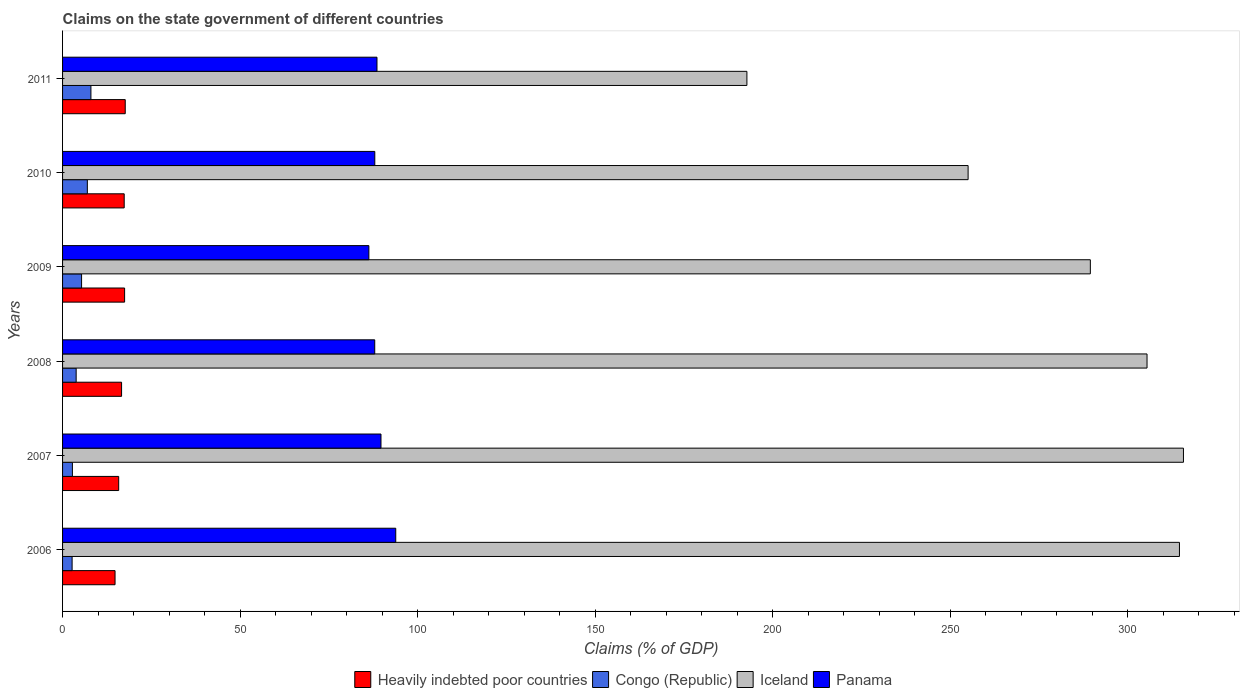How many different coloured bars are there?
Ensure brevity in your answer.  4. Are the number of bars per tick equal to the number of legend labels?
Your answer should be compact. Yes. Are the number of bars on each tick of the Y-axis equal?
Give a very brief answer. Yes. How many bars are there on the 3rd tick from the top?
Your answer should be very brief. 4. How many bars are there on the 1st tick from the bottom?
Keep it short and to the point. 4. What is the label of the 4th group of bars from the top?
Offer a terse response. 2008. In how many cases, is the number of bars for a given year not equal to the number of legend labels?
Give a very brief answer. 0. What is the percentage of GDP claimed on the state government in Congo (Republic) in 2009?
Give a very brief answer. 5.35. Across all years, what is the maximum percentage of GDP claimed on the state government in Iceland?
Your answer should be compact. 315.68. Across all years, what is the minimum percentage of GDP claimed on the state government in Panama?
Your response must be concise. 86.27. In which year was the percentage of GDP claimed on the state government in Congo (Republic) maximum?
Give a very brief answer. 2011. What is the total percentage of GDP claimed on the state government in Panama in the graph?
Ensure brevity in your answer.  534.18. What is the difference between the percentage of GDP claimed on the state government in Panama in 2006 and that in 2009?
Provide a short and direct response. 7.57. What is the difference between the percentage of GDP claimed on the state government in Heavily indebted poor countries in 2009 and the percentage of GDP claimed on the state government in Congo (Republic) in 2008?
Make the answer very short. 13.64. What is the average percentage of GDP claimed on the state government in Iceland per year?
Make the answer very short. 278.81. In the year 2007, what is the difference between the percentage of GDP claimed on the state government in Heavily indebted poor countries and percentage of GDP claimed on the state government in Congo (Republic)?
Your answer should be very brief. 13.03. What is the ratio of the percentage of GDP claimed on the state government in Iceland in 2006 to that in 2008?
Your response must be concise. 1.03. What is the difference between the highest and the second highest percentage of GDP claimed on the state government in Panama?
Provide a succinct answer. 4.16. What is the difference between the highest and the lowest percentage of GDP claimed on the state government in Iceland?
Offer a terse response. 122.94. In how many years, is the percentage of GDP claimed on the state government in Panama greater than the average percentage of GDP claimed on the state government in Panama taken over all years?
Your answer should be compact. 2. What does the 3rd bar from the top in 2011 represents?
Ensure brevity in your answer.  Congo (Republic). What does the 4th bar from the bottom in 2008 represents?
Offer a very short reply. Panama. Is it the case that in every year, the sum of the percentage of GDP claimed on the state government in Iceland and percentage of GDP claimed on the state government in Congo (Republic) is greater than the percentage of GDP claimed on the state government in Panama?
Provide a short and direct response. Yes. How many bars are there?
Provide a short and direct response. 24. What is the difference between two consecutive major ticks on the X-axis?
Your answer should be very brief. 50. Does the graph contain any zero values?
Keep it short and to the point. No. Does the graph contain grids?
Ensure brevity in your answer.  No. How many legend labels are there?
Make the answer very short. 4. What is the title of the graph?
Your response must be concise. Claims on the state government of different countries. Does "Caribbean small states" appear as one of the legend labels in the graph?
Keep it short and to the point. No. What is the label or title of the X-axis?
Offer a terse response. Claims (% of GDP). What is the Claims (% of GDP) in Heavily indebted poor countries in 2006?
Your answer should be very brief. 14.78. What is the Claims (% of GDP) in Congo (Republic) in 2006?
Keep it short and to the point. 2.69. What is the Claims (% of GDP) of Iceland in 2006?
Offer a very short reply. 314.55. What is the Claims (% of GDP) in Panama in 2006?
Your response must be concise. 93.84. What is the Claims (% of GDP) of Heavily indebted poor countries in 2007?
Make the answer very short. 15.81. What is the Claims (% of GDP) of Congo (Republic) in 2007?
Your answer should be compact. 2.77. What is the Claims (% of GDP) of Iceland in 2007?
Keep it short and to the point. 315.68. What is the Claims (% of GDP) of Panama in 2007?
Offer a very short reply. 89.68. What is the Claims (% of GDP) in Heavily indebted poor countries in 2008?
Your answer should be very brief. 16.62. What is the Claims (% of GDP) in Congo (Republic) in 2008?
Provide a succinct answer. 3.83. What is the Claims (% of GDP) of Iceland in 2008?
Offer a terse response. 305.42. What is the Claims (% of GDP) in Panama in 2008?
Keep it short and to the point. 87.92. What is the Claims (% of GDP) in Heavily indebted poor countries in 2009?
Offer a terse response. 17.47. What is the Claims (% of GDP) in Congo (Republic) in 2009?
Keep it short and to the point. 5.35. What is the Claims (% of GDP) in Iceland in 2009?
Your answer should be compact. 289.45. What is the Claims (% of GDP) of Panama in 2009?
Your response must be concise. 86.27. What is the Claims (% of GDP) in Heavily indebted poor countries in 2010?
Provide a short and direct response. 17.36. What is the Claims (% of GDP) in Congo (Republic) in 2010?
Your answer should be very brief. 6.98. What is the Claims (% of GDP) in Iceland in 2010?
Offer a very short reply. 255.03. What is the Claims (% of GDP) of Panama in 2010?
Provide a short and direct response. 87.94. What is the Claims (% of GDP) in Heavily indebted poor countries in 2011?
Make the answer very short. 17.65. What is the Claims (% of GDP) in Congo (Republic) in 2011?
Make the answer very short. 7.99. What is the Claims (% of GDP) of Iceland in 2011?
Ensure brevity in your answer.  192.73. What is the Claims (% of GDP) in Panama in 2011?
Give a very brief answer. 88.55. Across all years, what is the maximum Claims (% of GDP) of Heavily indebted poor countries?
Give a very brief answer. 17.65. Across all years, what is the maximum Claims (% of GDP) in Congo (Republic)?
Offer a terse response. 7.99. Across all years, what is the maximum Claims (% of GDP) in Iceland?
Your answer should be compact. 315.68. Across all years, what is the maximum Claims (% of GDP) in Panama?
Provide a short and direct response. 93.84. Across all years, what is the minimum Claims (% of GDP) of Heavily indebted poor countries?
Offer a very short reply. 14.78. Across all years, what is the minimum Claims (% of GDP) in Congo (Republic)?
Your answer should be very brief. 2.69. Across all years, what is the minimum Claims (% of GDP) in Iceland?
Provide a short and direct response. 192.73. Across all years, what is the minimum Claims (% of GDP) of Panama?
Offer a very short reply. 86.27. What is the total Claims (% of GDP) in Heavily indebted poor countries in the graph?
Give a very brief answer. 99.69. What is the total Claims (% of GDP) of Congo (Republic) in the graph?
Ensure brevity in your answer.  29.61. What is the total Claims (% of GDP) in Iceland in the graph?
Your answer should be very brief. 1672.86. What is the total Claims (% of GDP) of Panama in the graph?
Offer a terse response. 534.18. What is the difference between the Claims (% of GDP) in Heavily indebted poor countries in 2006 and that in 2007?
Your answer should be compact. -1.03. What is the difference between the Claims (% of GDP) of Congo (Republic) in 2006 and that in 2007?
Offer a very short reply. -0.08. What is the difference between the Claims (% of GDP) in Iceland in 2006 and that in 2007?
Provide a short and direct response. -1.13. What is the difference between the Claims (% of GDP) in Panama in 2006 and that in 2007?
Your answer should be compact. 4.16. What is the difference between the Claims (% of GDP) in Heavily indebted poor countries in 2006 and that in 2008?
Your response must be concise. -1.84. What is the difference between the Claims (% of GDP) in Congo (Republic) in 2006 and that in 2008?
Ensure brevity in your answer.  -1.14. What is the difference between the Claims (% of GDP) in Iceland in 2006 and that in 2008?
Give a very brief answer. 9.13. What is the difference between the Claims (% of GDP) in Panama in 2006 and that in 2008?
Give a very brief answer. 5.92. What is the difference between the Claims (% of GDP) in Heavily indebted poor countries in 2006 and that in 2009?
Your answer should be very brief. -2.69. What is the difference between the Claims (% of GDP) in Congo (Republic) in 2006 and that in 2009?
Provide a short and direct response. -2.67. What is the difference between the Claims (% of GDP) in Iceland in 2006 and that in 2009?
Keep it short and to the point. 25.09. What is the difference between the Claims (% of GDP) in Panama in 2006 and that in 2009?
Provide a short and direct response. 7.57. What is the difference between the Claims (% of GDP) in Heavily indebted poor countries in 2006 and that in 2010?
Make the answer very short. -2.58. What is the difference between the Claims (% of GDP) in Congo (Republic) in 2006 and that in 2010?
Offer a very short reply. -4.29. What is the difference between the Claims (% of GDP) of Iceland in 2006 and that in 2010?
Provide a short and direct response. 59.52. What is the difference between the Claims (% of GDP) of Panama in 2006 and that in 2010?
Provide a succinct answer. 5.9. What is the difference between the Claims (% of GDP) in Heavily indebted poor countries in 2006 and that in 2011?
Your answer should be very brief. -2.87. What is the difference between the Claims (% of GDP) of Congo (Republic) in 2006 and that in 2011?
Make the answer very short. -5.3. What is the difference between the Claims (% of GDP) in Iceland in 2006 and that in 2011?
Provide a succinct answer. 121.81. What is the difference between the Claims (% of GDP) in Panama in 2006 and that in 2011?
Offer a terse response. 5.29. What is the difference between the Claims (% of GDP) in Heavily indebted poor countries in 2007 and that in 2008?
Ensure brevity in your answer.  -0.81. What is the difference between the Claims (% of GDP) in Congo (Republic) in 2007 and that in 2008?
Provide a short and direct response. -1.06. What is the difference between the Claims (% of GDP) in Iceland in 2007 and that in 2008?
Offer a terse response. 10.26. What is the difference between the Claims (% of GDP) of Panama in 2007 and that in 2008?
Provide a succinct answer. 1.76. What is the difference between the Claims (% of GDP) of Heavily indebted poor countries in 2007 and that in 2009?
Offer a terse response. -1.67. What is the difference between the Claims (% of GDP) in Congo (Republic) in 2007 and that in 2009?
Ensure brevity in your answer.  -2.58. What is the difference between the Claims (% of GDP) in Iceland in 2007 and that in 2009?
Offer a terse response. 26.22. What is the difference between the Claims (% of GDP) of Panama in 2007 and that in 2009?
Provide a short and direct response. 3.41. What is the difference between the Claims (% of GDP) of Heavily indebted poor countries in 2007 and that in 2010?
Your response must be concise. -1.55. What is the difference between the Claims (% of GDP) of Congo (Republic) in 2007 and that in 2010?
Provide a short and direct response. -4.21. What is the difference between the Claims (% of GDP) of Iceland in 2007 and that in 2010?
Give a very brief answer. 60.65. What is the difference between the Claims (% of GDP) in Panama in 2007 and that in 2010?
Your answer should be compact. 1.74. What is the difference between the Claims (% of GDP) in Heavily indebted poor countries in 2007 and that in 2011?
Your answer should be compact. -1.84. What is the difference between the Claims (% of GDP) in Congo (Republic) in 2007 and that in 2011?
Give a very brief answer. -5.21. What is the difference between the Claims (% of GDP) of Iceland in 2007 and that in 2011?
Your answer should be very brief. 122.94. What is the difference between the Claims (% of GDP) of Panama in 2007 and that in 2011?
Ensure brevity in your answer.  1.13. What is the difference between the Claims (% of GDP) of Heavily indebted poor countries in 2008 and that in 2009?
Offer a very short reply. -0.85. What is the difference between the Claims (% of GDP) of Congo (Republic) in 2008 and that in 2009?
Make the answer very short. -1.53. What is the difference between the Claims (% of GDP) in Iceland in 2008 and that in 2009?
Your answer should be very brief. 15.96. What is the difference between the Claims (% of GDP) in Panama in 2008 and that in 2009?
Give a very brief answer. 1.65. What is the difference between the Claims (% of GDP) of Heavily indebted poor countries in 2008 and that in 2010?
Your answer should be compact. -0.74. What is the difference between the Claims (% of GDP) in Congo (Republic) in 2008 and that in 2010?
Offer a very short reply. -3.15. What is the difference between the Claims (% of GDP) in Iceland in 2008 and that in 2010?
Make the answer very short. 50.39. What is the difference between the Claims (% of GDP) in Panama in 2008 and that in 2010?
Your answer should be very brief. -0.02. What is the difference between the Claims (% of GDP) in Heavily indebted poor countries in 2008 and that in 2011?
Provide a succinct answer. -1.03. What is the difference between the Claims (% of GDP) of Congo (Republic) in 2008 and that in 2011?
Provide a short and direct response. -4.16. What is the difference between the Claims (% of GDP) of Iceland in 2008 and that in 2011?
Your response must be concise. 112.69. What is the difference between the Claims (% of GDP) of Panama in 2008 and that in 2011?
Make the answer very short. -0.63. What is the difference between the Claims (% of GDP) of Heavily indebted poor countries in 2009 and that in 2010?
Give a very brief answer. 0.12. What is the difference between the Claims (% of GDP) in Congo (Republic) in 2009 and that in 2010?
Provide a short and direct response. -1.62. What is the difference between the Claims (% of GDP) in Iceland in 2009 and that in 2010?
Keep it short and to the point. 34.43. What is the difference between the Claims (% of GDP) in Panama in 2009 and that in 2010?
Ensure brevity in your answer.  -1.67. What is the difference between the Claims (% of GDP) of Heavily indebted poor countries in 2009 and that in 2011?
Your response must be concise. -0.18. What is the difference between the Claims (% of GDP) in Congo (Republic) in 2009 and that in 2011?
Your response must be concise. -2.63. What is the difference between the Claims (% of GDP) in Iceland in 2009 and that in 2011?
Ensure brevity in your answer.  96.72. What is the difference between the Claims (% of GDP) of Panama in 2009 and that in 2011?
Your answer should be compact. -2.28. What is the difference between the Claims (% of GDP) in Heavily indebted poor countries in 2010 and that in 2011?
Ensure brevity in your answer.  -0.29. What is the difference between the Claims (% of GDP) of Congo (Republic) in 2010 and that in 2011?
Give a very brief answer. -1.01. What is the difference between the Claims (% of GDP) in Iceland in 2010 and that in 2011?
Offer a terse response. 62.29. What is the difference between the Claims (% of GDP) in Panama in 2010 and that in 2011?
Offer a very short reply. -0.61. What is the difference between the Claims (% of GDP) in Heavily indebted poor countries in 2006 and the Claims (% of GDP) in Congo (Republic) in 2007?
Offer a terse response. 12.01. What is the difference between the Claims (% of GDP) of Heavily indebted poor countries in 2006 and the Claims (% of GDP) of Iceland in 2007?
Give a very brief answer. -300.89. What is the difference between the Claims (% of GDP) of Heavily indebted poor countries in 2006 and the Claims (% of GDP) of Panama in 2007?
Offer a very short reply. -74.9. What is the difference between the Claims (% of GDP) of Congo (Republic) in 2006 and the Claims (% of GDP) of Iceland in 2007?
Make the answer very short. -312.99. What is the difference between the Claims (% of GDP) of Congo (Republic) in 2006 and the Claims (% of GDP) of Panama in 2007?
Give a very brief answer. -86.99. What is the difference between the Claims (% of GDP) in Iceland in 2006 and the Claims (% of GDP) in Panama in 2007?
Your answer should be compact. 224.87. What is the difference between the Claims (% of GDP) of Heavily indebted poor countries in 2006 and the Claims (% of GDP) of Congo (Republic) in 2008?
Your answer should be compact. 10.95. What is the difference between the Claims (% of GDP) of Heavily indebted poor countries in 2006 and the Claims (% of GDP) of Iceland in 2008?
Make the answer very short. -290.64. What is the difference between the Claims (% of GDP) of Heavily indebted poor countries in 2006 and the Claims (% of GDP) of Panama in 2008?
Provide a short and direct response. -73.14. What is the difference between the Claims (% of GDP) in Congo (Republic) in 2006 and the Claims (% of GDP) in Iceland in 2008?
Offer a terse response. -302.73. What is the difference between the Claims (% of GDP) in Congo (Republic) in 2006 and the Claims (% of GDP) in Panama in 2008?
Offer a very short reply. -85.23. What is the difference between the Claims (% of GDP) of Iceland in 2006 and the Claims (% of GDP) of Panama in 2008?
Provide a short and direct response. 226.63. What is the difference between the Claims (% of GDP) in Heavily indebted poor countries in 2006 and the Claims (% of GDP) in Congo (Republic) in 2009?
Offer a very short reply. 9.43. What is the difference between the Claims (% of GDP) of Heavily indebted poor countries in 2006 and the Claims (% of GDP) of Iceland in 2009?
Your response must be concise. -274.67. What is the difference between the Claims (% of GDP) in Heavily indebted poor countries in 2006 and the Claims (% of GDP) in Panama in 2009?
Provide a succinct answer. -71.48. What is the difference between the Claims (% of GDP) of Congo (Republic) in 2006 and the Claims (% of GDP) of Iceland in 2009?
Make the answer very short. -286.77. What is the difference between the Claims (% of GDP) in Congo (Republic) in 2006 and the Claims (% of GDP) in Panama in 2009?
Offer a terse response. -83.58. What is the difference between the Claims (% of GDP) of Iceland in 2006 and the Claims (% of GDP) of Panama in 2009?
Provide a succinct answer. 228.28. What is the difference between the Claims (% of GDP) in Heavily indebted poor countries in 2006 and the Claims (% of GDP) in Congo (Republic) in 2010?
Make the answer very short. 7.8. What is the difference between the Claims (% of GDP) in Heavily indebted poor countries in 2006 and the Claims (% of GDP) in Iceland in 2010?
Your answer should be very brief. -240.25. What is the difference between the Claims (% of GDP) in Heavily indebted poor countries in 2006 and the Claims (% of GDP) in Panama in 2010?
Offer a very short reply. -73.16. What is the difference between the Claims (% of GDP) of Congo (Republic) in 2006 and the Claims (% of GDP) of Iceland in 2010?
Make the answer very short. -252.34. What is the difference between the Claims (% of GDP) in Congo (Republic) in 2006 and the Claims (% of GDP) in Panama in 2010?
Ensure brevity in your answer.  -85.25. What is the difference between the Claims (% of GDP) in Iceland in 2006 and the Claims (% of GDP) in Panama in 2010?
Keep it short and to the point. 226.61. What is the difference between the Claims (% of GDP) in Heavily indebted poor countries in 2006 and the Claims (% of GDP) in Congo (Republic) in 2011?
Offer a very short reply. 6.79. What is the difference between the Claims (% of GDP) in Heavily indebted poor countries in 2006 and the Claims (% of GDP) in Iceland in 2011?
Offer a very short reply. -177.95. What is the difference between the Claims (% of GDP) in Heavily indebted poor countries in 2006 and the Claims (% of GDP) in Panama in 2011?
Offer a very short reply. -73.77. What is the difference between the Claims (% of GDP) in Congo (Republic) in 2006 and the Claims (% of GDP) in Iceland in 2011?
Your response must be concise. -190.05. What is the difference between the Claims (% of GDP) of Congo (Republic) in 2006 and the Claims (% of GDP) of Panama in 2011?
Offer a terse response. -85.86. What is the difference between the Claims (% of GDP) in Iceland in 2006 and the Claims (% of GDP) in Panama in 2011?
Your response must be concise. 226. What is the difference between the Claims (% of GDP) of Heavily indebted poor countries in 2007 and the Claims (% of GDP) of Congo (Republic) in 2008?
Provide a short and direct response. 11.98. What is the difference between the Claims (% of GDP) in Heavily indebted poor countries in 2007 and the Claims (% of GDP) in Iceland in 2008?
Give a very brief answer. -289.61. What is the difference between the Claims (% of GDP) in Heavily indebted poor countries in 2007 and the Claims (% of GDP) in Panama in 2008?
Offer a very short reply. -72.11. What is the difference between the Claims (% of GDP) of Congo (Republic) in 2007 and the Claims (% of GDP) of Iceland in 2008?
Keep it short and to the point. -302.65. What is the difference between the Claims (% of GDP) of Congo (Republic) in 2007 and the Claims (% of GDP) of Panama in 2008?
Ensure brevity in your answer.  -85.15. What is the difference between the Claims (% of GDP) of Iceland in 2007 and the Claims (% of GDP) of Panama in 2008?
Give a very brief answer. 227.76. What is the difference between the Claims (% of GDP) of Heavily indebted poor countries in 2007 and the Claims (% of GDP) of Congo (Republic) in 2009?
Ensure brevity in your answer.  10.45. What is the difference between the Claims (% of GDP) in Heavily indebted poor countries in 2007 and the Claims (% of GDP) in Iceland in 2009?
Ensure brevity in your answer.  -273.65. What is the difference between the Claims (% of GDP) of Heavily indebted poor countries in 2007 and the Claims (% of GDP) of Panama in 2009?
Offer a very short reply. -70.46. What is the difference between the Claims (% of GDP) in Congo (Republic) in 2007 and the Claims (% of GDP) in Iceland in 2009?
Your answer should be very brief. -286.68. What is the difference between the Claims (% of GDP) in Congo (Republic) in 2007 and the Claims (% of GDP) in Panama in 2009?
Provide a succinct answer. -83.49. What is the difference between the Claims (% of GDP) of Iceland in 2007 and the Claims (% of GDP) of Panama in 2009?
Your answer should be compact. 229.41. What is the difference between the Claims (% of GDP) in Heavily indebted poor countries in 2007 and the Claims (% of GDP) in Congo (Republic) in 2010?
Offer a very short reply. 8.83. What is the difference between the Claims (% of GDP) in Heavily indebted poor countries in 2007 and the Claims (% of GDP) in Iceland in 2010?
Provide a succinct answer. -239.22. What is the difference between the Claims (% of GDP) in Heavily indebted poor countries in 2007 and the Claims (% of GDP) in Panama in 2010?
Offer a very short reply. -72.13. What is the difference between the Claims (% of GDP) in Congo (Republic) in 2007 and the Claims (% of GDP) in Iceland in 2010?
Provide a short and direct response. -252.26. What is the difference between the Claims (% of GDP) of Congo (Republic) in 2007 and the Claims (% of GDP) of Panama in 2010?
Keep it short and to the point. -85.16. What is the difference between the Claims (% of GDP) of Iceland in 2007 and the Claims (% of GDP) of Panama in 2010?
Make the answer very short. 227.74. What is the difference between the Claims (% of GDP) in Heavily indebted poor countries in 2007 and the Claims (% of GDP) in Congo (Republic) in 2011?
Offer a terse response. 7.82. What is the difference between the Claims (% of GDP) of Heavily indebted poor countries in 2007 and the Claims (% of GDP) of Iceland in 2011?
Ensure brevity in your answer.  -176.93. What is the difference between the Claims (% of GDP) of Heavily indebted poor countries in 2007 and the Claims (% of GDP) of Panama in 2011?
Your answer should be compact. -72.74. What is the difference between the Claims (% of GDP) of Congo (Republic) in 2007 and the Claims (% of GDP) of Iceland in 2011?
Give a very brief answer. -189.96. What is the difference between the Claims (% of GDP) of Congo (Republic) in 2007 and the Claims (% of GDP) of Panama in 2011?
Your response must be concise. -85.78. What is the difference between the Claims (% of GDP) in Iceland in 2007 and the Claims (% of GDP) in Panama in 2011?
Your response must be concise. 227.13. What is the difference between the Claims (% of GDP) in Heavily indebted poor countries in 2008 and the Claims (% of GDP) in Congo (Republic) in 2009?
Give a very brief answer. 11.27. What is the difference between the Claims (% of GDP) in Heavily indebted poor countries in 2008 and the Claims (% of GDP) in Iceland in 2009?
Provide a short and direct response. -272.83. What is the difference between the Claims (% of GDP) in Heavily indebted poor countries in 2008 and the Claims (% of GDP) in Panama in 2009?
Offer a terse response. -69.65. What is the difference between the Claims (% of GDP) in Congo (Republic) in 2008 and the Claims (% of GDP) in Iceland in 2009?
Keep it short and to the point. -285.63. What is the difference between the Claims (% of GDP) of Congo (Republic) in 2008 and the Claims (% of GDP) of Panama in 2009?
Make the answer very short. -82.44. What is the difference between the Claims (% of GDP) in Iceland in 2008 and the Claims (% of GDP) in Panama in 2009?
Provide a short and direct response. 219.15. What is the difference between the Claims (% of GDP) in Heavily indebted poor countries in 2008 and the Claims (% of GDP) in Congo (Republic) in 2010?
Give a very brief answer. 9.64. What is the difference between the Claims (% of GDP) of Heavily indebted poor countries in 2008 and the Claims (% of GDP) of Iceland in 2010?
Provide a short and direct response. -238.41. What is the difference between the Claims (% of GDP) of Heavily indebted poor countries in 2008 and the Claims (% of GDP) of Panama in 2010?
Offer a terse response. -71.32. What is the difference between the Claims (% of GDP) of Congo (Republic) in 2008 and the Claims (% of GDP) of Iceland in 2010?
Offer a terse response. -251.2. What is the difference between the Claims (% of GDP) in Congo (Republic) in 2008 and the Claims (% of GDP) in Panama in 2010?
Your answer should be compact. -84.11. What is the difference between the Claims (% of GDP) in Iceland in 2008 and the Claims (% of GDP) in Panama in 2010?
Offer a terse response. 217.48. What is the difference between the Claims (% of GDP) of Heavily indebted poor countries in 2008 and the Claims (% of GDP) of Congo (Republic) in 2011?
Make the answer very short. 8.63. What is the difference between the Claims (% of GDP) of Heavily indebted poor countries in 2008 and the Claims (% of GDP) of Iceland in 2011?
Your answer should be very brief. -176.11. What is the difference between the Claims (% of GDP) in Heavily indebted poor countries in 2008 and the Claims (% of GDP) in Panama in 2011?
Your answer should be compact. -71.93. What is the difference between the Claims (% of GDP) of Congo (Republic) in 2008 and the Claims (% of GDP) of Iceland in 2011?
Make the answer very short. -188.91. What is the difference between the Claims (% of GDP) of Congo (Republic) in 2008 and the Claims (% of GDP) of Panama in 2011?
Your answer should be compact. -84.72. What is the difference between the Claims (% of GDP) of Iceland in 2008 and the Claims (% of GDP) of Panama in 2011?
Offer a very short reply. 216.87. What is the difference between the Claims (% of GDP) of Heavily indebted poor countries in 2009 and the Claims (% of GDP) of Congo (Republic) in 2010?
Your answer should be compact. 10.49. What is the difference between the Claims (% of GDP) in Heavily indebted poor countries in 2009 and the Claims (% of GDP) in Iceland in 2010?
Ensure brevity in your answer.  -237.56. What is the difference between the Claims (% of GDP) of Heavily indebted poor countries in 2009 and the Claims (% of GDP) of Panama in 2010?
Your answer should be compact. -70.46. What is the difference between the Claims (% of GDP) in Congo (Republic) in 2009 and the Claims (% of GDP) in Iceland in 2010?
Your answer should be compact. -249.67. What is the difference between the Claims (% of GDP) of Congo (Republic) in 2009 and the Claims (% of GDP) of Panama in 2010?
Ensure brevity in your answer.  -82.58. What is the difference between the Claims (% of GDP) of Iceland in 2009 and the Claims (% of GDP) of Panama in 2010?
Make the answer very short. 201.52. What is the difference between the Claims (% of GDP) in Heavily indebted poor countries in 2009 and the Claims (% of GDP) in Congo (Republic) in 2011?
Your response must be concise. 9.49. What is the difference between the Claims (% of GDP) in Heavily indebted poor countries in 2009 and the Claims (% of GDP) in Iceland in 2011?
Your response must be concise. -175.26. What is the difference between the Claims (% of GDP) of Heavily indebted poor countries in 2009 and the Claims (% of GDP) of Panama in 2011?
Make the answer very short. -71.08. What is the difference between the Claims (% of GDP) in Congo (Republic) in 2009 and the Claims (% of GDP) in Iceland in 2011?
Your answer should be compact. -187.38. What is the difference between the Claims (% of GDP) in Congo (Republic) in 2009 and the Claims (% of GDP) in Panama in 2011?
Your answer should be compact. -83.2. What is the difference between the Claims (% of GDP) of Iceland in 2009 and the Claims (% of GDP) of Panama in 2011?
Offer a very short reply. 200.91. What is the difference between the Claims (% of GDP) of Heavily indebted poor countries in 2010 and the Claims (% of GDP) of Congo (Republic) in 2011?
Offer a very short reply. 9.37. What is the difference between the Claims (% of GDP) in Heavily indebted poor countries in 2010 and the Claims (% of GDP) in Iceland in 2011?
Ensure brevity in your answer.  -175.38. What is the difference between the Claims (% of GDP) of Heavily indebted poor countries in 2010 and the Claims (% of GDP) of Panama in 2011?
Provide a succinct answer. -71.19. What is the difference between the Claims (% of GDP) of Congo (Republic) in 2010 and the Claims (% of GDP) of Iceland in 2011?
Offer a terse response. -185.75. What is the difference between the Claims (% of GDP) of Congo (Republic) in 2010 and the Claims (% of GDP) of Panama in 2011?
Your answer should be very brief. -81.57. What is the difference between the Claims (% of GDP) in Iceland in 2010 and the Claims (% of GDP) in Panama in 2011?
Ensure brevity in your answer.  166.48. What is the average Claims (% of GDP) in Heavily indebted poor countries per year?
Make the answer very short. 16.61. What is the average Claims (% of GDP) of Congo (Republic) per year?
Give a very brief answer. 4.93. What is the average Claims (% of GDP) in Iceland per year?
Provide a succinct answer. 278.81. What is the average Claims (% of GDP) in Panama per year?
Make the answer very short. 89.03. In the year 2006, what is the difference between the Claims (% of GDP) of Heavily indebted poor countries and Claims (% of GDP) of Congo (Republic)?
Your answer should be very brief. 12.09. In the year 2006, what is the difference between the Claims (% of GDP) of Heavily indebted poor countries and Claims (% of GDP) of Iceland?
Offer a terse response. -299.77. In the year 2006, what is the difference between the Claims (% of GDP) in Heavily indebted poor countries and Claims (% of GDP) in Panama?
Offer a very short reply. -79.06. In the year 2006, what is the difference between the Claims (% of GDP) in Congo (Republic) and Claims (% of GDP) in Iceland?
Make the answer very short. -311.86. In the year 2006, what is the difference between the Claims (% of GDP) of Congo (Republic) and Claims (% of GDP) of Panama?
Ensure brevity in your answer.  -91.15. In the year 2006, what is the difference between the Claims (% of GDP) in Iceland and Claims (% of GDP) in Panama?
Offer a very short reply. 220.71. In the year 2007, what is the difference between the Claims (% of GDP) in Heavily indebted poor countries and Claims (% of GDP) in Congo (Republic)?
Your response must be concise. 13.03. In the year 2007, what is the difference between the Claims (% of GDP) in Heavily indebted poor countries and Claims (% of GDP) in Iceland?
Keep it short and to the point. -299.87. In the year 2007, what is the difference between the Claims (% of GDP) in Heavily indebted poor countries and Claims (% of GDP) in Panama?
Ensure brevity in your answer.  -73.87. In the year 2007, what is the difference between the Claims (% of GDP) in Congo (Republic) and Claims (% of GDP) in Iceland?
Make the answer very short. -312.9. In the year 2007, what is the difference between the Claims (% of GDP) in Congo (Republic) and Claims (% of GDP) in Panama?
Offer a very short reply. -86.91. In the year 2007, what is the difference between the Claims (% of GDP) of Iceland and Claims (% of GDP) of Panama?
Your answer should be very brief. 226. In the year 2008, what is the difference between the Claims (% of GDP) in Heavily indebted poor countries and Claims (% of GDP) in Congo (Republic)?
Your answer should be compact. 12.79. In the year 2008, what is the difference between the Claims (% of GDP) in Heavily indebted poor countries and Claims (% of GDP) in Iceland?
Give a very brief answer. -288.8. In the year 2008, what is the difference between the Claims (% of GDP) in Heavily indebted poor countries and Claims (% of GDP) in Panama?
Keep it short and to the point. -71.3. In the year 2008, what is the difference between the Claims (% of GDP) of Congo (Republic) and Claims (% of GDP) of Iceland?
Keep it short and to the point. -301.59. In the year 2008, what is the difference between the Claims (% of GDP) in Congo (Republic) and Claims (% of GDP) in Panama?
Your answer should be compact. -84.09. In the year 2008, what is the difference between the Claims (% of GDP) in Iceland and Claims (% of GDP) in Panama?
Provide a succinct answer. 217.5. In the year 2009, what is the difference between the Claims (% of GDP) of Heavily indebted poor countries and Claims (% of GDP) of Congo (Republic)?
Provide a short and direct response. 12.12. In the year 2009, what is the difference between the Claims (% of GDP) in Heavily indebted poor countries and Claims (% of GDP) in Iceland?
Provide a succinct answer. -271.98. In the year 2009, what is the difference between the Claims (% of GDP) in Heavily indebted poor countries and Claims (% of GDP) in Panama?
Provide a succinct answer. -68.79. In the year 2009, what is the difference between the Claims (% of GDP) in Congo (Republic) and Claims (% of GDP) in Iceland?
Your answer should be very brief. -284.1. In the year 2009, what is the difference between the Claims (% of GDP) in Congo (Republic) and Claims (% of GDP) in Panama?
Your answer should be compact. -80.91. In the year 2009, what is the difference between the Claims (% of GDP) in Iceland and Claims (% of GDP) in Panama?
Your answer should be very brief. 203.19. In the year 2010, what is the difference between the Claims (% of GDP) in Heavily indebted poor countries and Claims (% of GDP) in Congo (Republic)?
Provide a succinct answer. 10.38. In the year 2010, what is the difference between the Claims (% of GDP) in Heavily indebted poor countries and Claims (% of GDP) in Iceland?
Provide a short and direct response. -237.67. In the year 2010, what is the difference between the Claims (% of GDP) in Heavily indebted poor countries and Claims (% of GDP) in Panama?
Provide a succinct answer. -70.58. In the year 2010, what is the difference between the Claims (% of GDP) in Congo (Republic) and Claims (% of GDP) in Iceland?
Give a very brief answer. -248.05. In the year 2010, what is the difference between the Claims (% of GDP) in Congo (Republic) and Claims (% of GDP) in Panama?
Keep it short and to the point. -80.96. In the year 2010, what is the difference between the Claims (% of GDP) in Iceland and Claims (% of GDP) in Panama?
Ensure brevity in your answer.  167.09. In the year 2011, what is the difference between the Claims (% of GDP) of Heavily indebted poor countries and Claims (% of GDP) of Congo (Republic)?
Your response must be concise. 9.66. In the year 2011, what is the difference between the Claims (% of GDP) of Heavily indebted poor countries and Claims (% of GDP) of Iceland?
Make the answer very short. -175.08. In the year 2011, what is the difference between the Claims (% of GDP) of Heavily indebted poor countries and Claims (% of GDP) of Panama?
Your answer should be compact. -70.9. In the year 2011, what is the difference between the Claims (% of GDP) of Congo (Republic) and Claims (% of GDP) of Iceland?
Keep it short and to the point. -184.75. In the year 2011, what is the difference between the Claims (% of GDP) of Congo (Republic) and Claims (% of GDP) of Panama?
Ensure brevity in your answer.  -80.56. In the year 2011, what is the difference between the Claims (% of GDP) of Iceland and Claims (% of GDP) of Panama?
Your response must be concise. 104.18. What is the ratio of the Claims (% of GDP) in Heavily indebted poor countries in 2006 to that in 2007?
Keep it short and to the point. 0.94. What is the ratio of the Claims (% of GDP) of Congo (Republic) in 2006 to that in 2007?
Make the answer very short. 0.97. What is the ratio of the Claims (% of GDP) of Panama in 2006 to that in 2007?
Ensure brevity in your answer.  1.05. What is the ratio of the Claims (% of GDP) in Heavily indebted poor countries in 2006 to that in 2008?
Ensure brevity in your answer.  0.89. What is the ratio of the Claims (% of GDP) of Congo (Republic) in 2006 to that in 2008?
Your answer should be compact. 0.7. What is the ratio of the Claims (% of GDP) in Iceland in 2006 to that in 2008?
Your answer should be compact. 1.03. What is the ratio of the Claims (% of GDP) of Panama in 2006 to that in 2008?
Give a very brief answer. 1.07. What is the ratio of the Claims (% of GDP) in Heavily indebted poor countries in 2006 to that in 2009?
Ensure brevity in your answer.  0.85. What is the ratio of the Claims (% of GDP) in Congo (Republic) in 2006 to that in 2009?
Your answer should be compact. 0.5. What is the ratio of the Claims (% of GDP) of Iceland in 2006 to that in 2009?
Make the answer very short. 1.09. What is the ratio of the Claims (% of GDP) of Panama in 2006 to that in 2009?
Your answer should be compact. 1.09. What is the ratio of the Claims (% of GDP) of Heavily indebted poor countries in 2006 to that in 2010?
Provide a succinct answer. 0.85. What is the ratio of the Claims (% of GDP) of Congo (Republic) in 2006 to that in 2010?
Offer a very short reply. 0.39. What is the ratio of the Claims (% of GDP) in Iceland in 2006 to that in 2010?
Keep it short and to the point. 1.23. What is the ratio of the Claims (% of GDP) in Panama in 2006 to that in 2010?
Offer a very short reply. 1.07. What is the ratio of the Claims (% of GDP) of Heavily indebted poor countries in 2006 to that in 2011?
Your answer should be compact. 0.84. What is the ratio of the Claims (% of GDP) in Congo (Republic) in 2006 to that in 2011?
Offer a very short reply. 0.34. What is the ratio of the Claims (% of GDP) in Iceland in 2006 to that in 2011?
Your answer should be very brief. 1.63. What is the ratio of the Claims (% of GDP) in Panama in 2006 to that in 2011?
Your answer should be compact. 1.06. What is the ratio of the Claims (% of GDP) in Heavily indebted poor countries in 2007 to that in 2008?
Provide a short and direct response. 0.95. What is the ratio of the Claims (% of GDP) in Congo (Republic) in 2007 to that in 2008?
Your answer should be very brief. 0.72. What is the ratio of the Claims (% of GDP) in Iceland in 2007 to that in 2008?
Your response must be concise. 1.03. What is the ratio of the Claims (% of GDP) in Panama in 2007 to that in 2008?
Your answer should be very brief. 1.02. What is the ratio of the Claims (% of GDP) in Heavily indebted poor countries in 2007 to that in 2009?
Your answer should be very brief. 0.9. What is the ratio of the Claims (% of GDP) in Congo (Republic) in 2007 to that in 2009?
Give a very brief answer. 0.52. What is the ratio of the Claims (% of GDP) of Iceland in 2007 to that in 2009?
Your answer should be very brief. 1.09. What is the ratio of the Claims (% of GDP) in Panama in 2007 to that in 2009?
Your answer should be very brief. 1.04. What is the ratio of the Claims (% of GDP) in Heavily indebted poor countries in 2007 to that in 2010?
Offer a very short reply. 0.91. What is the ratio of the Claims (% of GDP) in Congo (Republic) in 2007 to that in 2010?
Make the answer very short. 0.4. What is the ratio of the Claims (% of GDP) of Iceland in 2007 to that in 2010?
Your answer should be compact. 1.24. What is the ratio of the Claims (% of GDP) of Panama in 2007 to that in 2010?
Provide a short and direct response. 1.02. What is the ratio of the Claims (% of GDP) in Heavily indebted poor countries in 2007 to that in 2011?
Your answer should be compact. 0.9. What is the ratio of the Claims (% of GDP) in Congo (Republic) in 2007 to that in 2011?
Your answer should be very brief. 0.35. What is the ratio of the Claims (% of GDP) of Iceland in 2007 to that in 2011?
Make the answer very short. 1.64. What is the ratio of the Claims (% of GDP) in Panama in 2007 to that in 2011?
Your answer should be compact. 1.01. What is the ratio of the Claims (% of GDP) of Heavily indebted poor countries in 2008 to that in 2009?
Give a very brief answer. 0.95. What is the ratio of the Claims (% of GDP) of Congo (Republic) in 2008 to that in 2009?
Your answer should be compact. 0.71. What is the ratio of the Claims (% of GDP) in Iceland in 2008 to that in 2009?
Provide a succinct answer. 1.06. What is the ratio of the Claims (% of GDP) of Panama in 2008 to that in 2009?
Make the answer very short. 1.02. What is the ratio of the Claims (% of GDP) in Heavily indebted poor countries in 2008 to that in 2010?
Your answer should be very brief. 0.96. What is the ratio of the Claims (% of GDP) in Congo (Republic) in 2008 to that in 2010?
Your answer should be compact. 0.55. What is the ratio of the Claims (% of GDP) in Iceland in 2008 to that in 2010?
Keep it short and to the point. 1.2. What is the ratio of the Claims (% of GDP) in Heavily indebted poor countries in 2008 to that in 2011?
Your response must be concise. 0.94. What is the ratio of the Claims (% of GDP) of Congo (Republic) in 2008 to that in 2011?
Your answer should be compact. 0.48. What is the ratio of the Claims (% of GDP) in Iceland in 2008 to that in 2011?
Provide a short and direct response. 1.58. What is the ratio of the Claims (% of GDP) of Panama in 2008 to that in 2011?
Keep it short and to the point. 0.99. What is the ratio of the Claims (% of GDP) of Heavily indebted poor countries in 2009 to that in 2010?
Offer a terse response. 1.01. What is the ratio of the Claims (% of GDP) of Congo (Republic) in 2009 to that in 2010?
Ensure brevity in your answer.  0.77. What is the ratio of the Claims (% of GDP) of Iceland in 2009 to that in 2010?
Provide a short and direct response. 1.14. What is the ratio of the Claims (% of GDP) of Heavily indebted poor countries in 2009 to that in 2011?
Ensure brevity in your answer.  0.99. What is the ratio of the Claims (% of GDP) of Congo (Republic) in 2009 to that in 2011?
Your answer should be compact. 0.67. What is the ratio of the Claims (% of GDP) of Iceland in 2009 to that in 2011?
Offer a very short reply. 1.5. What is the ratio of the Claims (% of GDP) of Panama in 2009 to that in 2011?
Your response must be concise. 0.97. What is the ratio of the Claims (% of GDP) in Heavily indebted poor countries in 2010 to that in 2011?
Provide a short and direct response. 0.98. What is the ratio of the Claims (% of GDP) in Congo (Republic) in 2010 to that in 2011?
Your response must be concise. 0.87. What is the ratio of the Claims (% of GDP) in Iceland in 2010 to that in 2011?
Your response must be concise. 1.32. What is the ratio of the Claims (% of GDP) in Panama in 2010 to that in 2011?
Offer a terse response. 0.99. What is the difference between the highest and the second highest Claims (% of GDP) of Heavily indebted poor countries?
Provide a succinct answer. 0.18. What is the difference between the highest and the second highest Claims (% of GDP) in Congo (Republic)?
Offer a very short reply. 1.01. What is the difference between the highest and the second highest Claims (% of GDP) in Iceland?
Provide a succinct answer. 1.13. What is the difference between the highest and the second highest Claims (% of GDP) in Panama?
Ensure brevity in your answer.  4.16. What is the difference between the highest and the lowest Claims (% of GDP) of Heavily indebted poor countries?
Ensure brevity in your answer.  2.87. What is the difference between the highest and the lowest Claims (% of GDP) in Congo (Republic)?
Provide a short and direct response. 5.3. What is the difference between the highest and the lowest Claims (% of GDP) in Iceland?
Provide a succinct answer. 122.94. What is the difference between the highest and the lowest Claims (% of GDP) of Panama?
Keep it short and to the point. 7.57. 